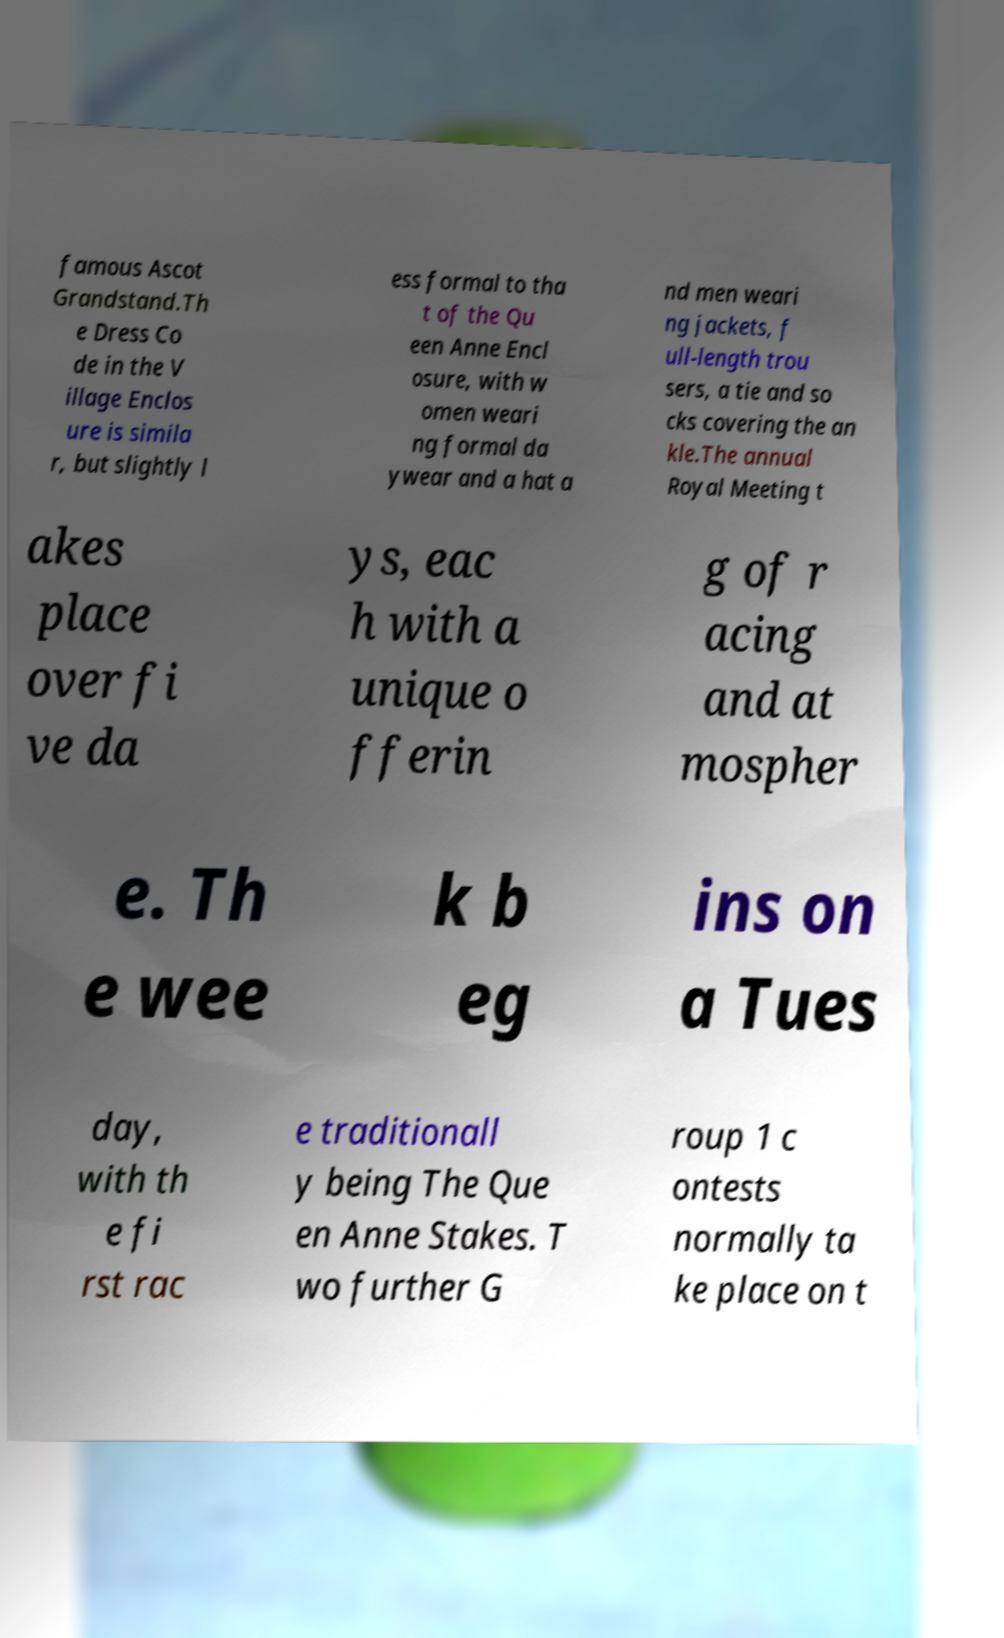There's text embedded in this image that I need extracted. Can you transcribe it verbatim? famous Ascot Grandstand.Th e Dress Co de in the V illage Enclos ure is simila r, but slightly l ess formal to tha t of the Qu een Anne Encl osure, with w omen weari ng formal da ywear and a hat a nd men weari ng jackets, f ull-length trou sers, a tie and so cks covering the an kle.The annual Royal Meeting t akes place over fi ve da ys, eac h with a unique o fferin g of r acing and at mospher e. Th e wee k b eg ins on a Tues day, with th e fi rst rac e traditionall y being The Que en Anne Stakes. T wo further G roup 1 c ontests normally ta ke place on t 